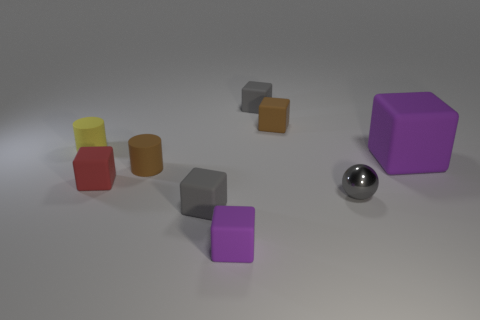Is there anything else that is the same material as the tiny ball?
Your answer should be compact. No. How many objects are either small objects that are in front of the red rubber block or big purple rubber things that are behind the tiny metal ball?
Provide a short and direct response. 4. There is another small rubber thing that is the same shape as the tiny yellow object; what color is it?
Your response must be concise. Brown. What number of small rubber blocks have the same color as the shiny sphere?
Your answer should be very brief. 2. Do the tiny metal sphere and the large thing have the same color?
Offer a terse response. No. What number of objects are either small rubber cylinders that are on the right side of the tiny red rubber cube or small brown rubber cylinders?
Give a very brief answer. 1. What color is the tiny cube that is right of the small object behind the brown rubber object that is behind the small yellow matte cylinder?
Your answer should be very brief. Brown. There is a large cube that is the same material as the small brown block; what is its color?
Make the answer very short. Purple. What number of small yellow objects are the same material as the small gray sphere?
Provide a short and direct response. 0. Is the size of the purple rubber thing behind the gray metallic thing the same as the yellow rubber thing?
Offer a terse response. No. 